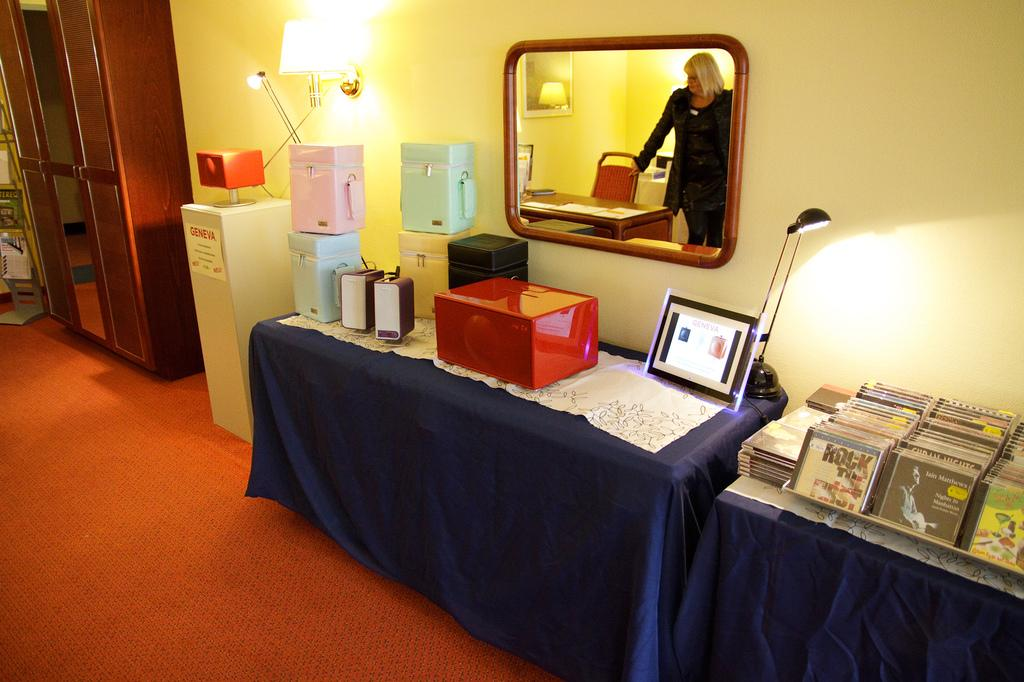<image>
Share a concise interpretation of the image provided. A framed sign on a table near a lamp has the word Geneva on it. 